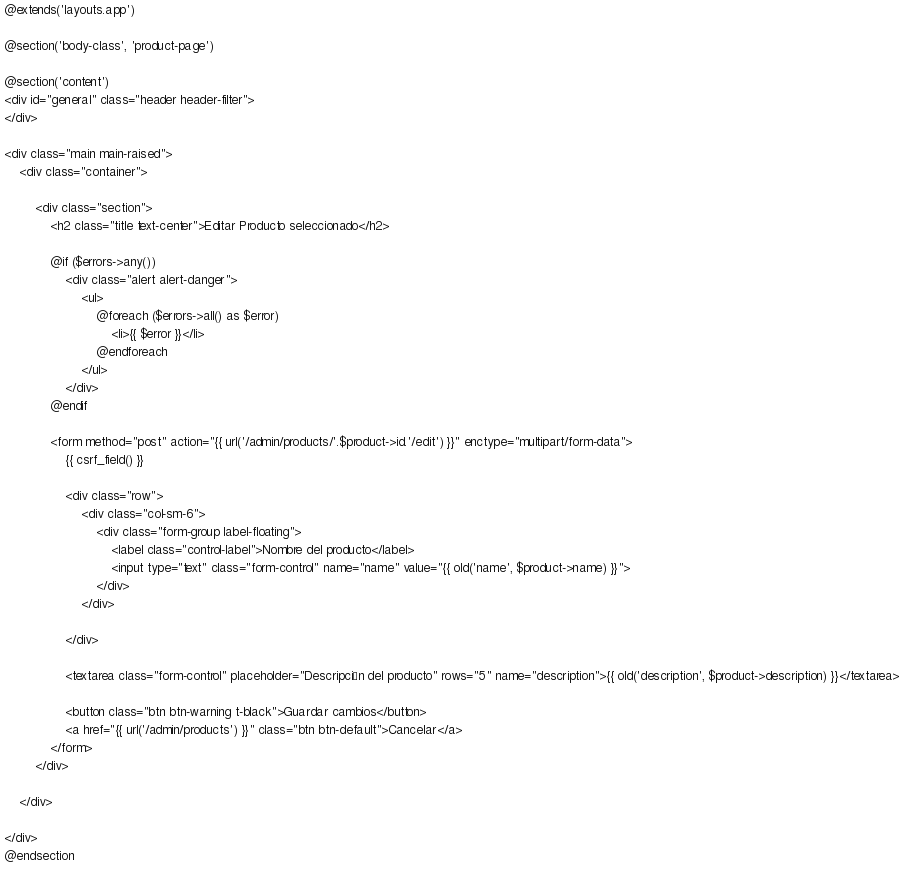<code> <loc_0><loc_0><loc_500><loc_500><_PHP_>@extends('layouts.app')

@section('body-class', 'product-page')

@section('content')
<div id="general" class="header header-filter">
</div>

<div class="main main-raised">
    <div class="container">

        <div class="section">
            <h2 class="title text-center">Editar Producto seleccionado</h2>

            @if ($errors->any())
                <div class="alert alert-danger">
                    <ul>
                        @foreach ($errors->all() as $error)
                            <li>{{ $error }}</li>
                        @endforeach
                    </ul>
                </div>
            @endif

            <form method="post" action="{{ url('/admin/products/'.$product->id.'/edit') }}" enctype="multipart/form-data">
                {{ csrf_field() }}

                <div class="row">
                    <div class="col-sm-6">
                        <div class="form-group label-floating">
                            <label class="control-label">Nombre del producto</label>
                            <input type="text" class="form-control" name="name" value="{{ old('name', $product->name) }}">
                        </div>
                    </div>
                              
                </div>

                <textarea class="form-control" placeholder="Descripción del producto" rows="5" name="description">{{ old('description', $product->description) }}</textarea>

                <button class="btn btn-warning t-black">Guardar cambios</button>
                <a href="{{ url('/admin/products') }}" class="btn btn-default">Cancelar</a>
            </form>
        </div>

    </div>

</div>
@endsection
</code> 